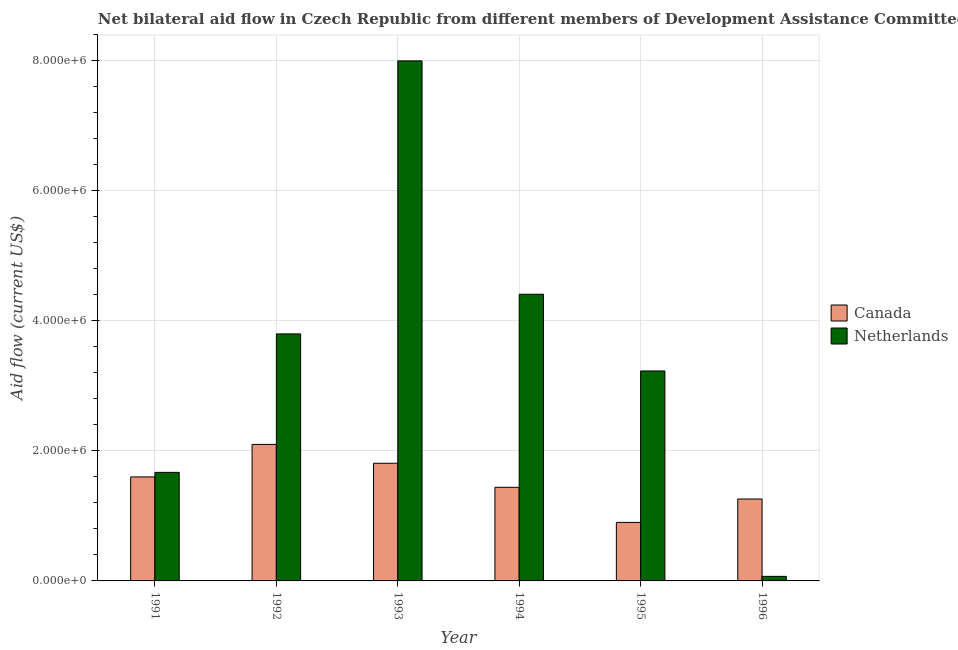How many groups of bars are there?
Keep it short and to the point. 6. Are the number of bars per tick equal to the number of legend labels?
Ensure brevity in your answer.  Yes. How many bars are there on the 5th tick from the right?
Offer a very short reply. 2. In how many cases, is the number of bars for a given year not equal to the number of legend labels?
Make the answer very short. 0. What is the amount of aid given by canada in 1991?
Your answer should be compact. 1.60e+06. Across all years, what is the maximum amount of aid given by netherlands?
Your response must be concise. 8.00e+06. Across all years, what is the minimum amount of aid given by netherlands?
Keep it short and to the point. 7.00e+04. In which year was the amount of aid given by canada minimum?
Keep it short and to the point. 1995. What is the total amount of aid given by netherlands in the graph?
Offer a terse response. 2.12e+07. What is the difference between the amount of aid given by canada in 1993 and that in 1995?
Your answer should be very brief. 9.10e+05. What is the difference between the amount of aid given by canada in 1995 and the amount of aid given by netherlands in 1993?
Your answer should be compact. -9.10e+05. What is the average amount of aid given by canada per year?
Keep it short and to the point. 1.52e+06. What is the ratio of the amount of aid given by netherlands in 1991 to that in 1994?
Your response must be concise. 0.38. What is the difference between the highest and the second highest amount of aid given by netherlands?
Your response must be concise. 3.59e+06. What is the difference between the highest and the lowest amount of aid given by netherlands?
Offer a terse response. 7.93e+06. In how many years, is the amount of aid given by canada greater than the average amount of aid given by canada taken over all years?
Your answer should be compact. 3. What does the 2nd bar from the left in 1992 represents?
Offer a very short reply. Netherlands. What does the 1st bar from the right in 1995 represents?
Provide a succinct answer. Netherlands. How many bars are there?
Your response must be concise. 12. Are all the bars in the graph horizontal?
Provide a succinct answer. No. Are the values on the major ticks of Y-axis written in scientific E-notation?
Give a very brief answer. Yes. Does the graph contain any zero values?
Your answer should be compact. No. Does the graph contain grids?
Your answer should be compact. Yes. How many legend labels are there?
Your response must be concise. 2. How are the legend labels stacked?
Your response must be concise. Vertical. What is the title of the graph?
Make the answer very short. Net bilateral aid flow in Czech Republic from different members of Development Assistance Committee. What is the label or title of the X-axis?
Your answer should be very brief. Year. What is the Aid flow (current US$) in Canada in 1991?
Your answer should be compact. 1.60e+06. What is the Aid flow (current US$) in Netherlands in 1991?
Keep it short and to the point. 1.67e+06. What is the Aid flow (current US$) of Canada in 1992?
Provide a short and direct response. 2.10e+06. What is the Aid flow (current US$) of Netherlands in 1992?
Provide a succinct answer. 3.80e+06. What is the Aid flow (current US$) of Canada in 1993?
Your answer should be very brief. 1.81e+06. What is the Aid flow (current US$) of Netherlands in 1993?
Offer a terse response. 8.00e+06. What is the Aid flow (current US$) in Canada in 1994?
Your answer should be compact. 1.44e+06. What is the Aid flow (current US$) in Netherlands in 1994?
Your answer should be compact. 4.41e+06. What is the Aid flow (current US$) of Canada in 1995?
Keep it short and to the point. 9.00e+05. What is the Aid flow (current US$) of Netherlands in 1995?
Your response must be concise. 3.23e+06. What is the Aid flow (current US$) in Canada in 1996?
Give a very brief answer. 1.26e+06. Across all years, what is the maximum Aid flow (current US$) in Canada?
Keep it short and to the point. 2.10e+06. Across all years, what is the maximum Aid flow (current US$) of Netherlands?
Your response must be concise. 8.00e+06. Across all years, what is the minimum Aid flow (current US$) in Netherlands?
Keep it short and to the point. 7.00e+04. What is the total Aid flow (current US$) in Canada in the graph?
Your answer should be very brief. 9.11e+06. What is the total Aid flow (current US$) in Netherlands in the graph?
Your answer should be very brief. 2.12e+07. What is the difference between the Aid flow (current US$) of Canada in 1991 and that in 1992?
Offer a terse response. -5.00e+05. What is the difference between the Aid flow (current US$) in Netherlands in 1991 and that in 1992?
Give a very brief answer. -2.13e+06. What is the difference between the Aid flow (current US$) of Canada in 1991 and that in 1993?
Offer a very short reply. -2.10e+05. What is the difference between the Aid flow (current US$) of Netherlands in 1991 and that in 1993?
Your response must be concise. -6.33e+06. What is the difference between the Aid flow (current US$) of Netherlands in 1991 and that in 1994?
Ensure brevity in your answer.  -2.74e+06. What is the difference between the Aid flow (current US$) in Canada in 1991 and that in 1995?
Give a very brief answer. 7.00e+05. What is the difference between the Aid flow (current US$) of Netherlands in 1991 and that in 1995?
Your answer should be compact. -1.56e+06. What is the difference between the Aid flow (current US$) in Canada in 1991 and that in 1996?
Your response must be concise. 3.40e+05. What is the difference between the Aid flow (current US$) in Netherlands in 1991 and that in 1996?
Provide a succinct answer. 1.60e+06. What is the difference between the Aid flow (current US$) of Netherlands in 1992 and that in 1993?
Ensure brevity in your answer.  -4.20e+06. What is the difference between the Aid flow (current US$) of Canada in 1992 and that in 1994?
Your answer should be compact. 6.60e+05. What is the difference between the Aid flow (current US$) of Netherlands in 1992 and that in 1994?
Your answer should be compact. -6.10e+05. What is the difference between the Aid flow (current US$) in Canada in 1992 and that in 1995?
Make the answer very short. 1.20e+06. What is the difference between the Aid flow (current US$) of Netherlands in 1992 and that in 1995?
Your answer should be very brief. 5.70e+05. What is the difference between the Aid flow (current US$) of Canada in 1992 and that in 1996?
Provide a short and direct response. 8.40e+05. What is the difference between the Aid flow (current US$) in Netherlands in 1992 and that in 1996?
Offer a terse response. 3.73e+06. What is the difference between the Aid flow (current US$) of Netherlands in 1993 and that in 1994?
Offer a terse response. 3.59e+06. What is the difference between the Aid flow (current US$) of Canada in 1993 and that in 1995?
Your response must be concise. 9.10e+05. What is the difference between the Aid flow (current US$) in Netherlands in 1993 and that in 1995?
Ensure brevity in your answer.  4.77e+06. What is the difference between the Aid flow (current US$) in Canada in 1993 and that in 1996?
Ensure brevity in your answer.  5.50e+05. What is the difference between the Aid flow (current US$) in Netherlands in 1993 and that in 1996?
Your answer should be very brief. 7.93e+06. What is the difference between the Aid flow (current US$) of Canada in 1994 and that in 1995?
Your answer should be very brief. 5.40e+05. What is the difference between the Aid flow (current US$) of Netherlands in 1994 and that in 1995?
Offer a terse response. 1.18e+06. What is the difference between the Aid flow (current US$) in Netherlands in 1994 and that in 1996?
Keep it short and to the point. 4.34e+06. What is the difference between the Aid flow (current US$) of Canada in 1995 and that in 1996?
Keep it short and to the point. -3.60e+05. What is the difference between the Aid flow (current US$) of Netherlands in 1995 and that in 1996?
Offer a very short reply. 3.16e+06. What is the difference between the Aid flow (current US$) of Canada in 1991 and the Aid flow (current US$) of Netherlands in 1992?
Make the answer very short. -2.20e+06. What is the difference between the Aid flow (current US$) of Canada in 1991 and the Aid flow (current US$) of Netherlands in 1993?
Provide a succinct answer. -6.40e+06. What is the difference between the Aid flow (current US$) of Canada in 1991 and the Aid flow (current US$) of Netherlands in 1994?
Ensure brevity in your answer.  -2.81e+06. What is the difference between the Aid flow (current US$) of Canada in 1991 and the Aid flow (current US$) of Netherlands in 1995?
Give a very brief answer. -1.63e+06. What is the difference between the Aid flow (current US$) of Canada in 1991 and the Aid flow (current US$) of Netherlands in 1996?
Make the answer very short. 1.53e+06. What is the difference between the Aid flow (current US$) of Canada in 1992 and the Aid flow (current US$) of Netherlands in 1993?
Your response must be concise. -5.90e+06. What is the difference between the Aid flow (current US$) of Canada in 1992 and the Aid flow (current US$) of Netherlands in 1994?
Your answer should be very brief. -2.31e+06. What is the difference between the Aid flow (current US$) in Canada in 1992 and the Aid flow (current US$) in Netherlands in 1995?
Provide a short and direct response. -1.13e+06. What is the difference between the Aid flow (current US$) in Canada in 1992 and the Aid flow (current US$) in Netherlands in 1996?
Your response must be concise. 2.03e+06. What is the difference between the Aid flow (current US$) in Canada in 1993 and the Aid flow (current US$) in Netherlands in 1994?
Provide a short and direct response. -2.60e+06. What is the difference between the Aid flow (current US$) in Canada in 1993 and the Aid flow (current US$) in Netherlands in 1995?
Keep it short and to the point. -1.42e+06. What is the difference between the Aid flow (current US$) in Canada in 1993 and the Aid flow (current US$) in Netherlands in 1996?
Give a very brief answer. 1.74e+06. What is the difference between the Aid flow (current US$) of Canada in 1994 and the Aid flow (current US$) of Netherlands in 1995?
Offer a very short reply. -1.79e+06. What is the difference between the Aid flow (current US$) in Canada in 1994 and the Aid flow (current US$) in Netherlands in 1996?
Offer a terse response. 1.37e+06. What is the difference between the Aid flow (current US$) of Canada in 1995 and the Aid flow (current US$) of Netherlands in 1996?
Your answer should be very brief. 8.30e+05. What is the average Aid flow (current US$) in Canada per year?
Your answer should be very brief. 1.52e+06. What is the average Aid flow (current US$) of Netherlands per year?
Give a very brief answer. 3.53e+06. In the year 1992, what is the difference between the Aid flow (current US$) in Canada and Aid flow (current US$) in Netherlands?
Your answer should be compact. -1.70e+06. In the year 1993, what is the difference between the Aid flow (current US$) of Canada and Aid flow (current US$) of Netherlands?
Make the answer very short. -6.19e+06. In the year 1994, what is the difference between the Aid flow (current US$) in Canada and Aid flow (current US$) in Netherlands?
Your response must be concise. -2.97e+06. In the year 1995, what is the difference between the Aid flow (current US$) in Canada and Aid flow (current US$) in Netherlands?
Your answer should be compact. -2.33e+06. In the year 1996, what is the difference between the Aid flow (current US$) in Canada and Aid flow (current US$) in Netherlands?
Your response must be concise. 1.19e+06. What is the ratio of the Aid flow (current US$) in Canada in 1991 to that in 1992?
Provide a succinct answer. 0.76. What is the ratio of the Aid flow (current US$) in Netherlands in 1991 to that in 1992?
Provide a short and direct response. 0.44. What is the ratio of the Aid flow (current US$) in Canada in 1991 to that in 1993?
Keep it short and to the point. 0.88. What is the ratio of the Aid flow (current US$) of Netherlands in 1991 to that in 1993?
Your answer should be very brief. 0.21. What is the ratio of the Aid flow (current US$) in Canada in 1991 to that in 1994?
Provide a short and direct response. 1.11. What is the ratio of the Aid flow (current US$) in Netherlands in 1991 to that in 1994?
Your answer should be compact. 0.38. What is the ratio of the Aid flow (current US$) of Canada in 1991 to that in 1995?
Provide a succinct answer. 1.78. What is the ratio of the Aid flow (current US$) in Netherlands in 1991 to that in 1995?
Keep it short and to the point. 0.52. What is the ratio of the Aid flow (current US$) of Canada in 1991 to that in 1996?
Give a very brief answer. 1.27. What is the ratio of the Aid flow (current US$) in Netherlands in 1991 to that in 1996?
Give a very brief answer. 23.86. What is the ratio of the Aid flow (current US$) in Canada in 1992 to that in 1993?
Your answer should be very brief. 1.16. What is the ratio of the Aid flow (current US$) in Netherlands in 1992 to that in 1993?
Make the answer very short. 0.47. What is the ratio of the Aid flow (current US$) in Canada in 1992 to that in 1994?
Your answer should be very brief. 1.46. What is the ratio of the Aid flow (current US$) of Netherlands in 1992 to that in 1994?
Offer a very short reply. 0.86. What is the ratio of the Aid flow (current US$) in Canada in 1992 to that in 1995?
Give a very brief answer. 2.33. What is the ratio of the Aid flow (current US$) of Netherlands in 1992 to that in 1995?
Give a very brief answer. 1.18. What is the ratio of the Aid flow (current US$) of Netherlands in 1992 to that in 1996?
Your response must be concise. 54.29. What is the ratio of the Aid flow (current US$) in Canada in 1993 to that in 1994?
Your response must be concise. 1.26. What is the ratio of the Aid flow (current US$) in Netherlands in 1993 to that in 1994?
Give a very brief answer. 1.81. What is the ratio of the Aid flow (current US$) of Canada in 1993 to that in 1995?
Give a very brief answer. 2.01. What is the ratio of the Aid flow (current US$) of Netherlands in 1993 to that in 1995?
Provide a short and direct response. 2.48. What is the ratio of the Aid flow (current US$) in Canada in 1993 to that in 1996?
Give a very brief answer. 1.44. What is the ratio of the Aid flow (current US$) of Netherlands in 1993 to that in 1996?
Make the answer very short. 114.29. What is the ratio of the Aid flow (current US$) in Canada in 1994 to that in 1995?
Keep it short and to the point. 1.6. What is the ratio of the Aid flow (current US$) of Netherlands in 1994 to that in 1995?
Provide a short and direct response. 1.37. What is the ratio of the Aid flow (current US$) of Canada in 1994 to that in 1996?
Give a very brief answer. 1.14. What is the ratio of the Aid flow (current US$) of Netherlands in 1995 to that in 1996?
Offer a terse response. 46.14. What is the difference between the highest and the second highest Aid flow (current US$) of Canada?
Provide a succinct answer. 2.90e+05. What is the difference between the highest and the second highest Aid flow (current US$) of Netherlands?
Make the answer very short. 3.59e+06. What is the difference between the highest and the lowest Aid flow (current US$) of Canada?
Offer a very short reply. 1.20e+06. What is the difference between the highest and the lowest Aid flow (current US$) of Netherlands?
Your response must be concise. 7.93e+06. 